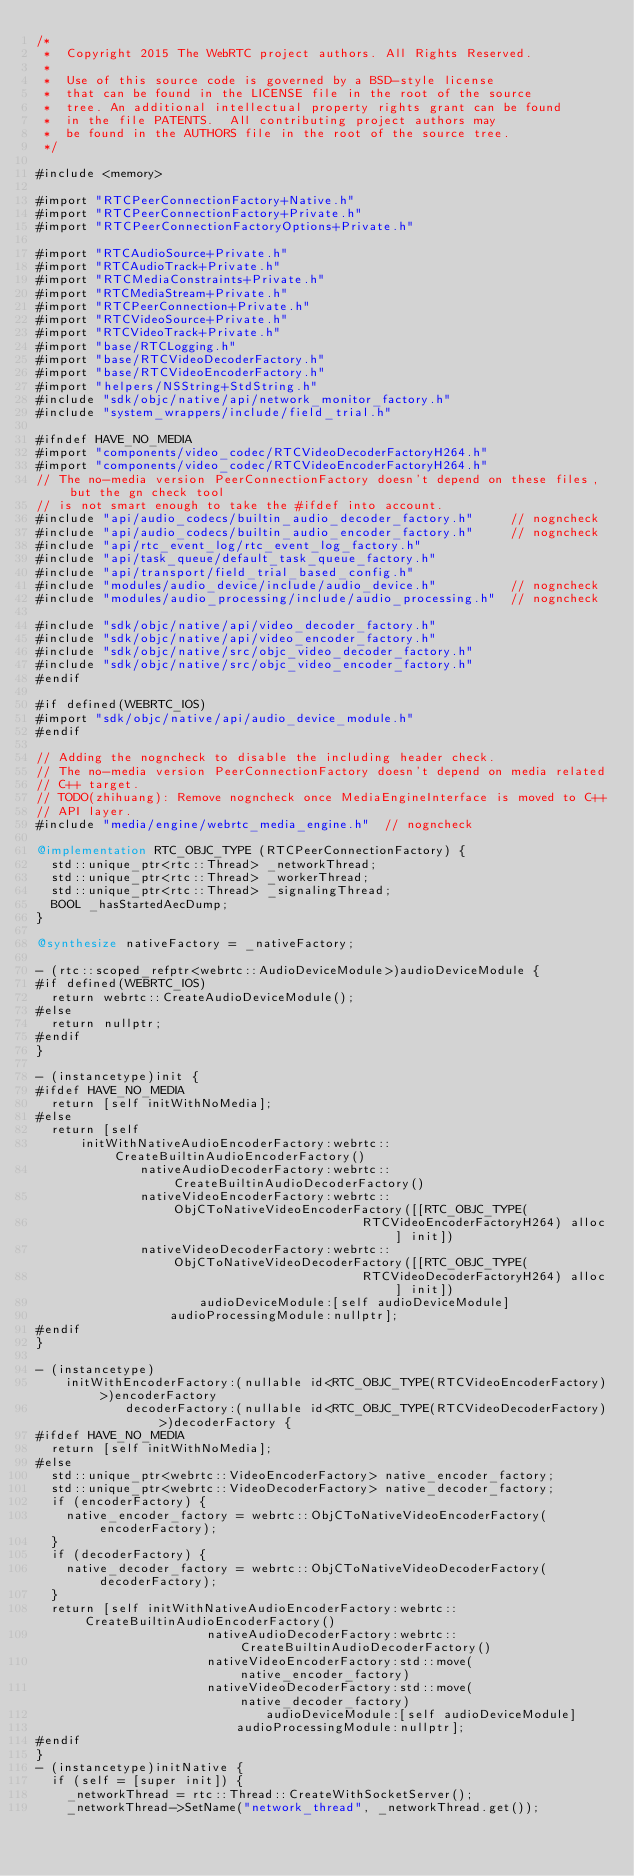<code> <loc_0><loc_0><loc_500><loc_500><_ObjectiveC_>/*
 *  Copyright 2015 The WebRTC project authors. All Rights Reserved.
 *
 *  Use of this source code is governed by a BSD-style license
 *  that can be found in the LICENSE file in the root of the source
 *  tree. An additional intellectual property rights grant can be found
 *  in the file PATENTS.  All contributing project authors may
 *  be found in the AUTHORS file in the root of the source tree.
 */

#include <memory>

#import "RTCPeerConnectionFactory+Native.h"
#import "RTCPeerConnectionFactory+Private.h"
#import "RTCPeerConnectionFactoryOptions+Private.h"

#import "RTCAudioSource+Private.h"
#import "RTCAudioTrack+Private.h"
#import "RTCMediaConstraints+Private.h"
#import "RTCMediaStream+Private.h"
#import "RTCPeerConnection+Private.h"
#import "RTCVideoSource+Private.h"
#import "RTCVideoTrack+Private.h"
#import "base/RTCLogging.h"
#import "base/RTCVideoDecoderFactory.h"
#import "base/RTCVideoEncoderFactory.h"
#import "helpers/NSString+StdString.h"
#include "sdk/objc/native/api/network_monitor_factory.h"
#include "system_wrappers/include/field_trial.h"

#ifndef HAVE_NO_MEDIA
#import "components/video_codec/RTCVideoDecoderFactoryH264.h"
#import "components/video_codec/RTCVideoEncoderFactoryH264.h"
// The no-media version PeerConnectionFactory doesn't depend on these files, but the gn check tool
// is not smart enough to take the #ifdef into account.
#include "api/audio_codecs/builtin_audio_decoder_factory.h"     // nogncheck
#include "api/audio_codecs/builtin_audio_encoder_factory.h"     // nogncheck
#include "api/rtc_event_log/rtc_event_log_factory.h"
#include "api/task_queue/default_task_queue_factory.h"
#include "api/transport/field_trial_based_config.h"
#include "modules/audio_device/include/audio_device.h"          // nogncheck
#include "modules/audio_processing/include/audio_processing.h"  // nogncheck

#include "sdk/objc/native/api/video_decoder_factory.h"
#include "sdk/objc/native/api/video_encoder_factory.h"
#include "sdk/objc/native/src/objc_video_decoder_factory.h"
#include "sdk/objc/native/src/objc_video_encoder_factory.h"
#endif

#if defined(WEBRTC_IOS)
#import "sdk/objc/native/api/audio_device_module.h"
#endif

// Adding the nogncheck to disable the including header check.
// The no-media version PeerConnectionFactory doesn't depend on media related
// C++ target.
// TODO(zhihuang): Remove nogncheck once MediaEngineInterface is moved to C++
// API layer.
#include "media/engine/webrtc_media_engine.h"  // nogncheck

@implementation RTC_OBJC_TYPE (RTCPeerConnectionFactory) {
  std::unique_ptr<rtc::Thread> _networkThread;
  std::unique_ptr<rtc::Thread> _workerThread;
  std::unique_ptr<rtc::Thread> _signalingThread;
  BOOL _hasStartedAecDump;
}

@synthesize nativeFactory = _nativeFactory;

- (rtc::scoped_refptr<webrtc::AudioDeviceModule>)audioDeviceModule {
#if defined(WEBRTC_IOS)
  return webrtc::CreateAudioDeviceModule();
#else
  return nullptr;
#endif
}

- (instancetype)init {
#ifdef HAVE_NO_MEDIA
  return [self initWithNoMedia];
#else
  return [self
      initWithNativeAudioEncoderFactory:webrtc::CreateBuiltinAudioEncoderFactory()
              nativeAudioDecoderFactory:webrtc::CreateBuiltinAudioDecoderFactory()
              nativeVideoEncoderFactory:webrtc::ObjCToNativeVideoEncoderFactory([[RTC_OBJC_TYPE(
                                            RTCVideoEncoderFactoryH264) alloc] init])
              nativeVideoDecoderFactory:webrtc::ObjCToNativeVideoDecoderFactory([[RTC_OBJC_TYPE(
                                            RTCVideoDecoderFactoryH264) alloc] init])
                      audioDeviceModule:[self audioDeviceModule]
                  audioProcessingModule:nullptr];
#endif
}

- (instancetype)
    initWithEncoderFactory:(nullable id<RTC_OBJC_TYPE(RTCVideoEncoderFactory)>)encoderFactory
            decoderFactory:(nullable id<RTC_OBJC_TYPE(RTCVideoDecoderFactory)>)decoderFactory {
#ifdef HAVE_NO_MEDIA
  return [self initWithNoMedia];
#else
  std::unique_ptr<webrtc::VideoEncoderFactory> native_encoder_factory;
  std::unique_ptr<webrtc::VideoDecoderFactory> native_decoder_factory;
  if (encoderFactory) {
    native_encoder_factory = webrtc::ObjCToNativeVideoEncoderFactory(encoderFactory);
  }
  if (decoderFactory) {
    native_decoder_factory = webrtc::ObjCToNativeVideoDecoderFactory(decoderFactory);
  }
  return [self initWithNativeAudioEncoderFactory:webrtc::CreateBuiltinAudioEncoderFactory()
                       nativeAudioDecoderFactory:webrtc::CreateBuiltinAudioDecoderFactory()
                       nativeVideoEncoderFactory:std::move(native_encoder_factory)
                       nativeVideoDecoderFactory:std::move(native_decoder_factory)
                               audioDeviceModule:[self audioDeviceModule]
                           audioProcessingModule:nullptr];
#endif
}
- (instancetype)initNative {
  if (self = [super init]) {
    _networkThread = rtc::Thread::CreateWithSocketServer();
    _networkThread->SetName("network_thread", _networkThread.get());</code> 